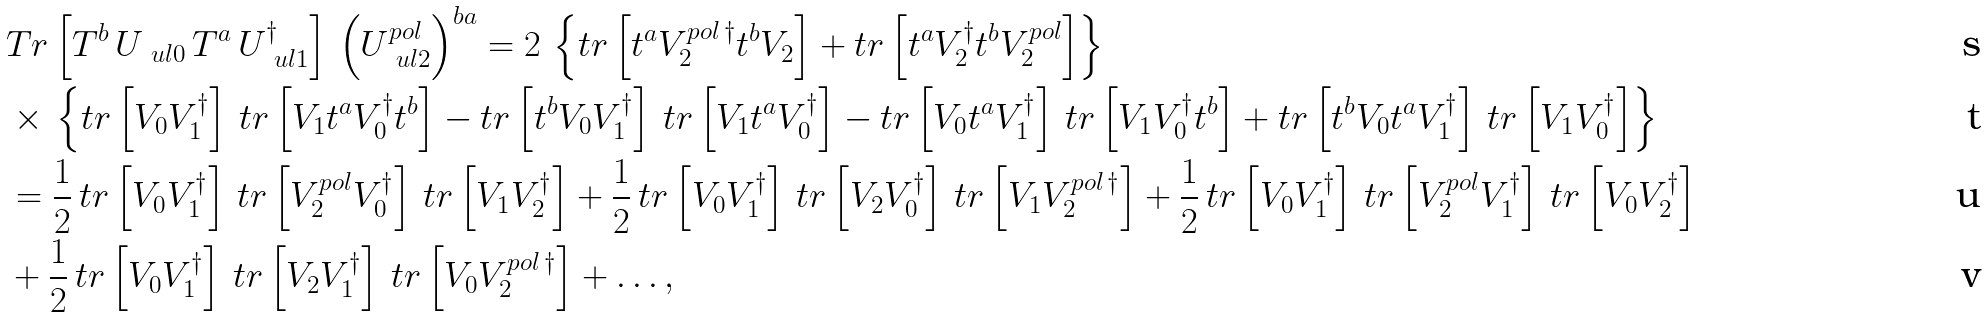<formula> <loc_0><loc_0><loc_500><loc_500>& T r \left [ T ^ { b } \, U _ { \ u l { 0 } } \, T ^ { a } \, U _ { \ u l { 1 } } ^ { \dagger } \right ] \, \left ( U ^ { p o l } _ { \ u l { 2 } } \right ) ^ { b a } = 2 \, \left \{ t r \left [ t ^ { a } V _ { 2 } ^ { p o l \, \dagger } t ^ { b } V _ { 2 } \right ] + t r \left [ t ^ { a } V _ { 2 } ^ { \dagger } t ^ { b } V _ { 2 } ^ { p o l } \right ] \right \} \\ & \times \, \left \{ t r \left [ V _ { 0 } V _ { 1 } ^ { \dagger } \right ] \, t r \left [ V _ { 1 } t ^ { a } V _ { 0 } ^ { \dagger } t ^ { b } \right ] - t r \left [ t ^ { b } V _ { 0 } V _ { 1 } ^ { \dagger } \right ] \, t r \left [ V _ { 1 } t ^ { a } V _ { 0 } ^ { \dagger } \right ] - t r \left [ V _ { 0 } t ^ { a } V _ { 1 } ^ { \dagger } \right ] \, t r \left [ V _ { 1 } V _ { 0 } ^ { \dagger } t ^ { b } \right ] + t r \left [ t ^ { b } V _ { 0 } t ^ { a } V _ { 1 } ^ { \dagger } \right ] \, t r \left [ V _ { 1 } V _ { 0 } ^ { \dagger } \right ] \right \} \\ & = \frac { 1 } { 2 } \, t r \left [ V _ { 0 } V _ { 1 } ^ { \dagger } \right ] \, t r \left [ V ^ { p o l } _ { 2 } V _ { 0 } ^ { \dagger } \right ] \, t r \left [ V _ { 1 } V _ { 2 } ^ { \dagger } \right ] + \frac { 1 } { 2 } \, t r \left [ V _ { 0 } V _ { 1 } ^ { \dagger } \right ] \, t r \left [ V _ { 2 } V _ { 0 } ^ { \dagger } \right ] \, t r \left [ V _ { 1 } V _ { 2 } ^ { p o l \, \dagger } \right ] + \frac { 1 } { 2 } \, t r \left [ V _ { 0 } V _ { 1 } ^ { \dagger } \right ] \, t r \left [ V ^ { p o l } _ { 2 } V _ { 1 } ^ { \dagger } \right ] \, t r \left [ V _ { 0 } V _ { 2 } ^ { \dagger } \right ] \\ & + \frac { 1 } { 2 } \, t r \left [ V _ { 0 } V _ { 1 } ^ { \dagger } \right ] \, t r \left [ V _ { 2 } V _ { 1 } ^ { \dagger } \right ] \, t r \left [ V _ { 0 } V _ { 2 } ^ { p o l \, \dagger } \right ] + \dots ,</formula> 